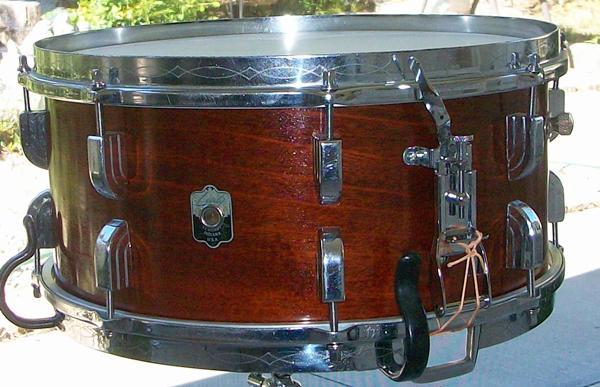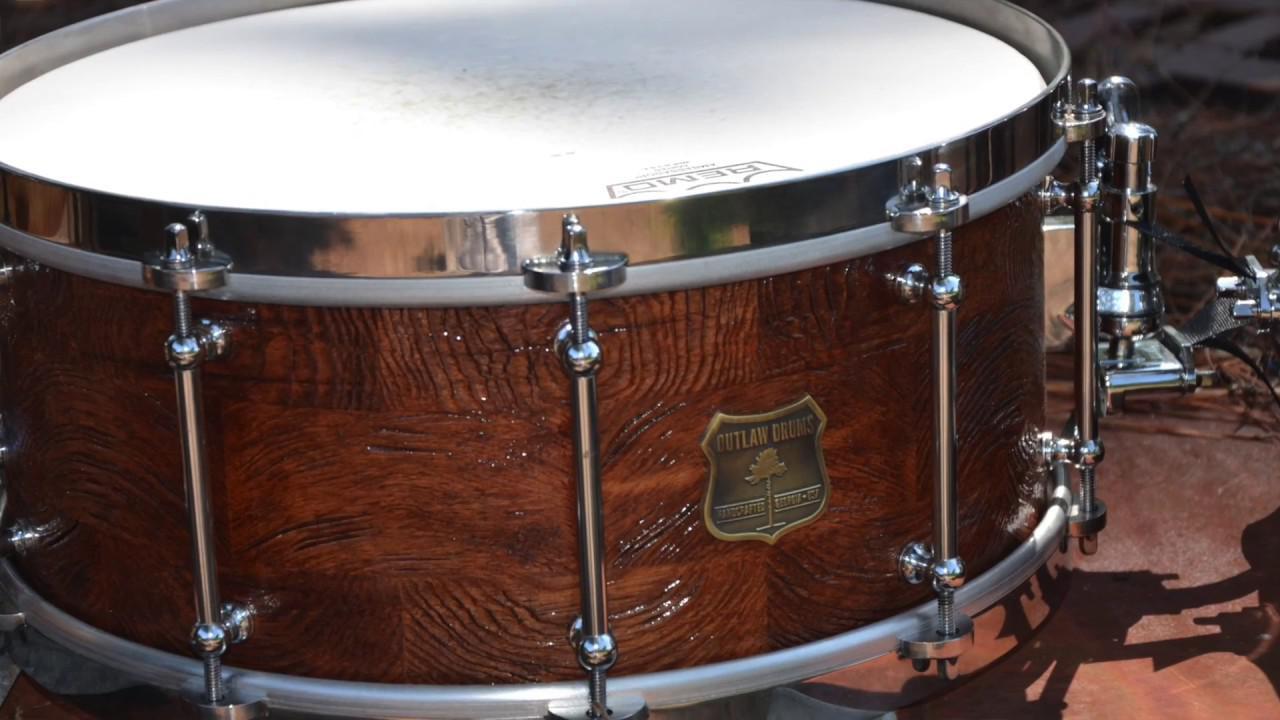The first image is the image on the left, the second image is the image on the right. For the images shown, is this caption "All drums are lying flat and one drum has an oval label that is facing directly forward." true? Answer yes or no. No. 